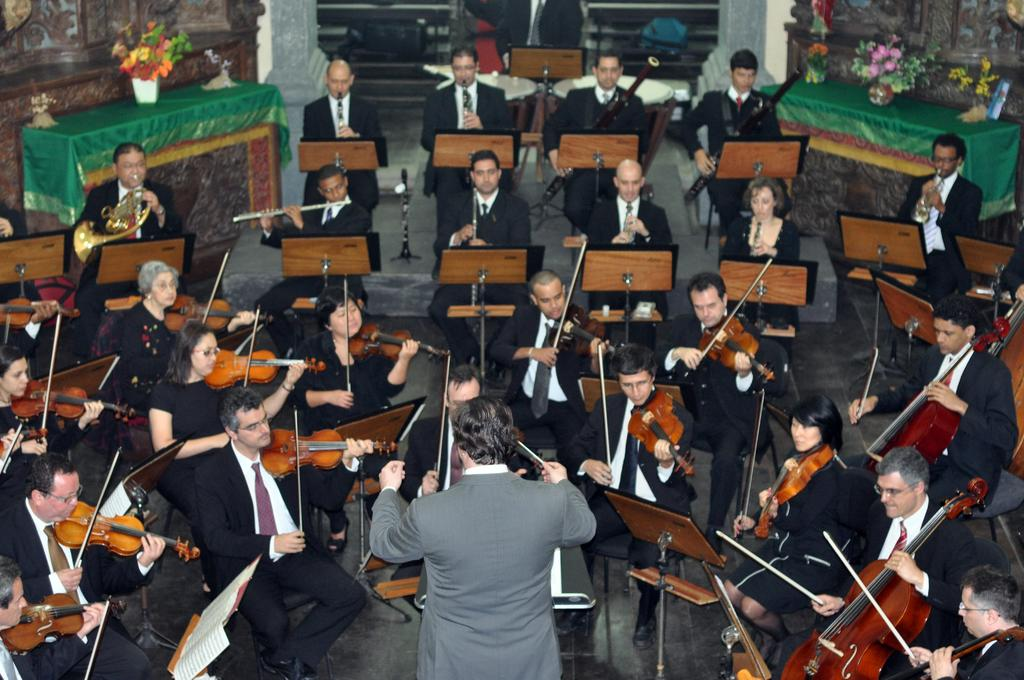How many people are in the image? There is a group of people in the image. What are some of the people doing in the image? Some people are sitting on chairs, playing musical instruments, and sitting on the floor. Can you describe the person near the podium? The person near the podium is wearing a suit. What type of rain is falling on the people in the image? There is no rain present in the image; it is an indoor setting. What theory is the person near the podium discussing in the image? There is no indication of a theory being discussed in the image; the person near the podium is simply wearing a suit. 